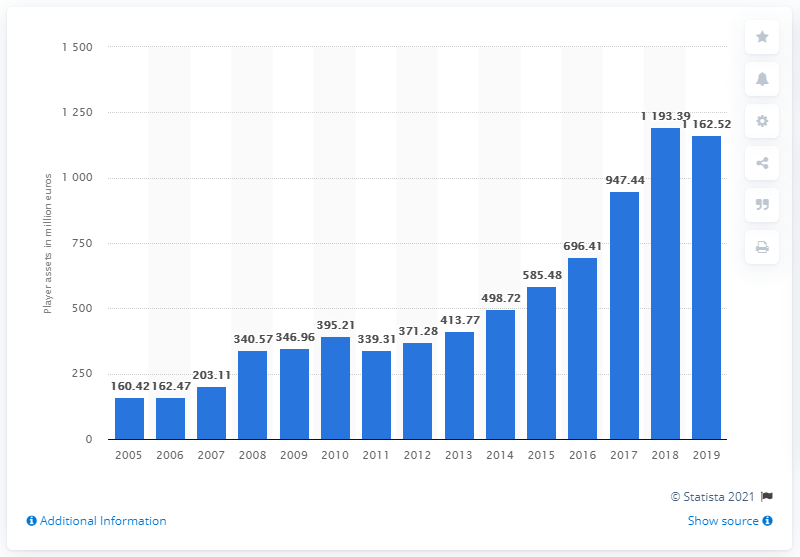Specify some key components in this picture. In 2019, the worth of player assets was $1,162.52. 